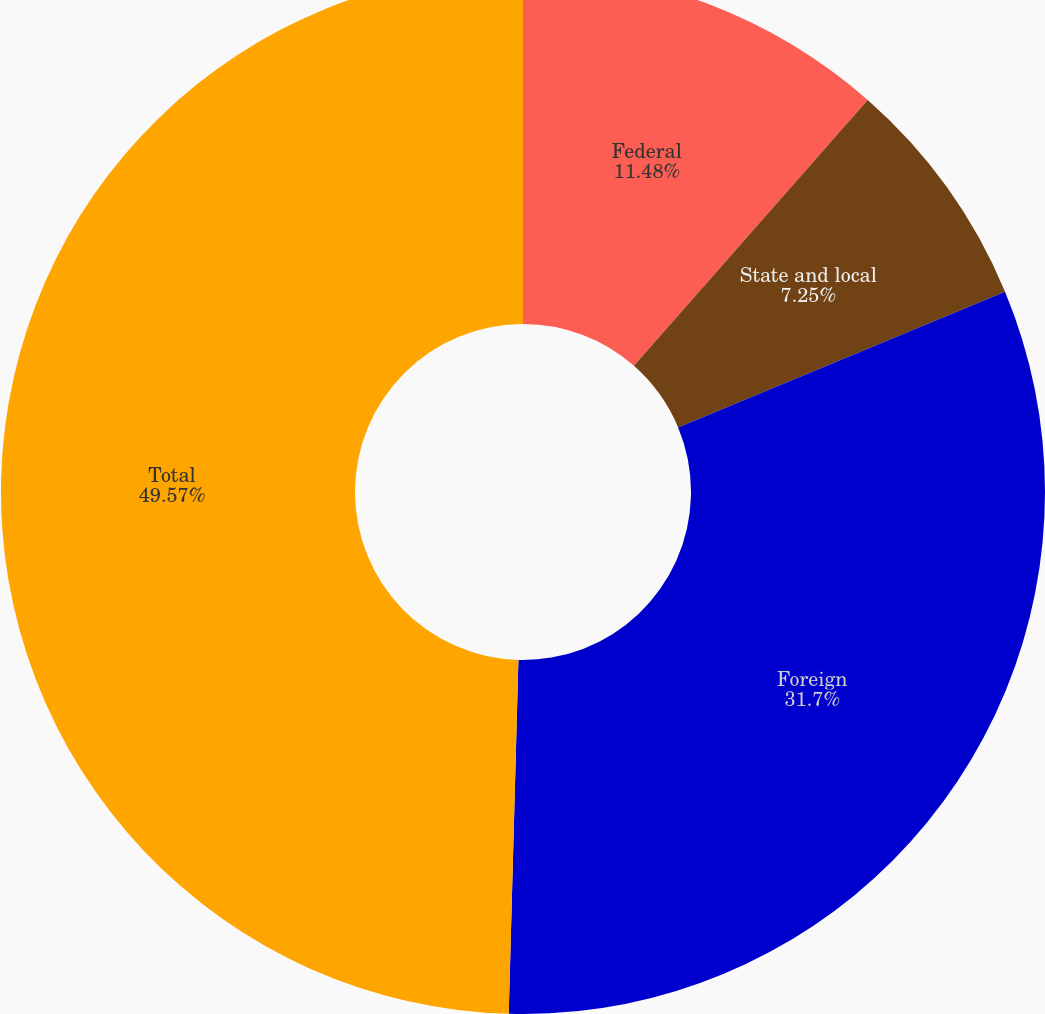Convert chart. <chart><loc_0><loc_0><loc_500><loc_500><pie_chart><fcel>Federal<fcel>State and local<fcel>Foreign<fcel>Total<nl><fcel>11.48%<fcel>7.25%<fcel>31.7%<fcel>49.56%<nl></chart> 